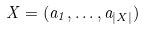Convert formula to latex. <formula><loc_0><loc_0><loc_500><loc_500>X = ( a _ { 1 } , \dots , a _ { | X | } )</formula> 